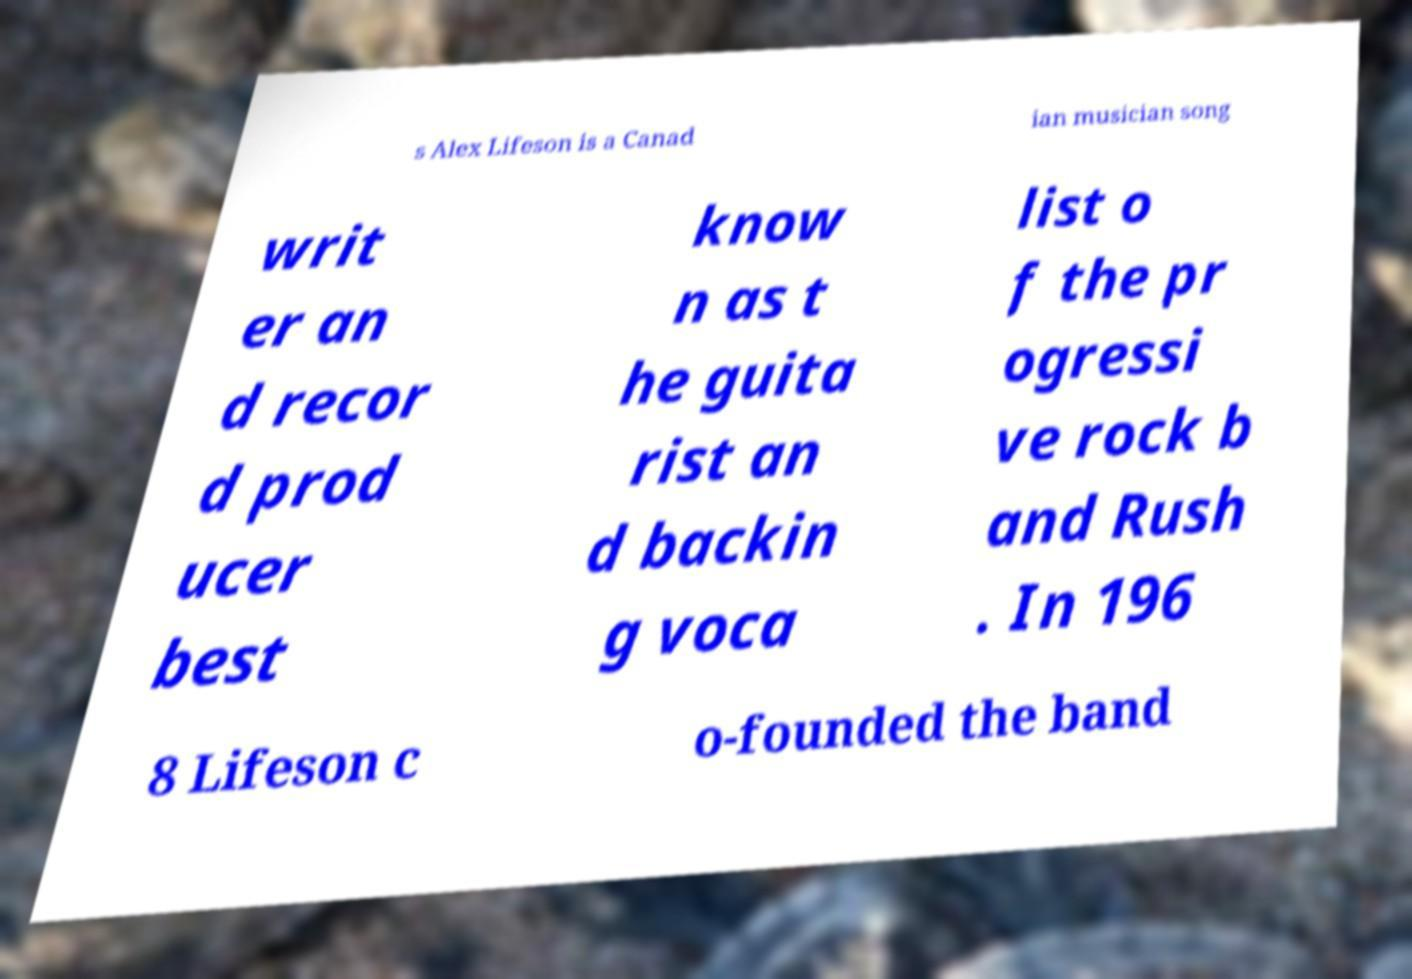Can you accurately transcribe the text from the provided image for me? s Alex Lifeson is a Canad ian musician song writ er an d recor d prod ucer best know n as t he guita rist an d backin g voca list o f the pr ogressi ve rock b and Rush . In 196 8 Lifeson c o-founded the band 